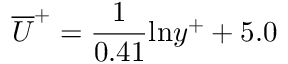<formula> <loc_0><loc_0><loc_500><loc_500>\overline { U } ^ { + } = \frac { 1 } { 0 . 4 1 } \ln y ^ { + } + 5 . 0</formula> 